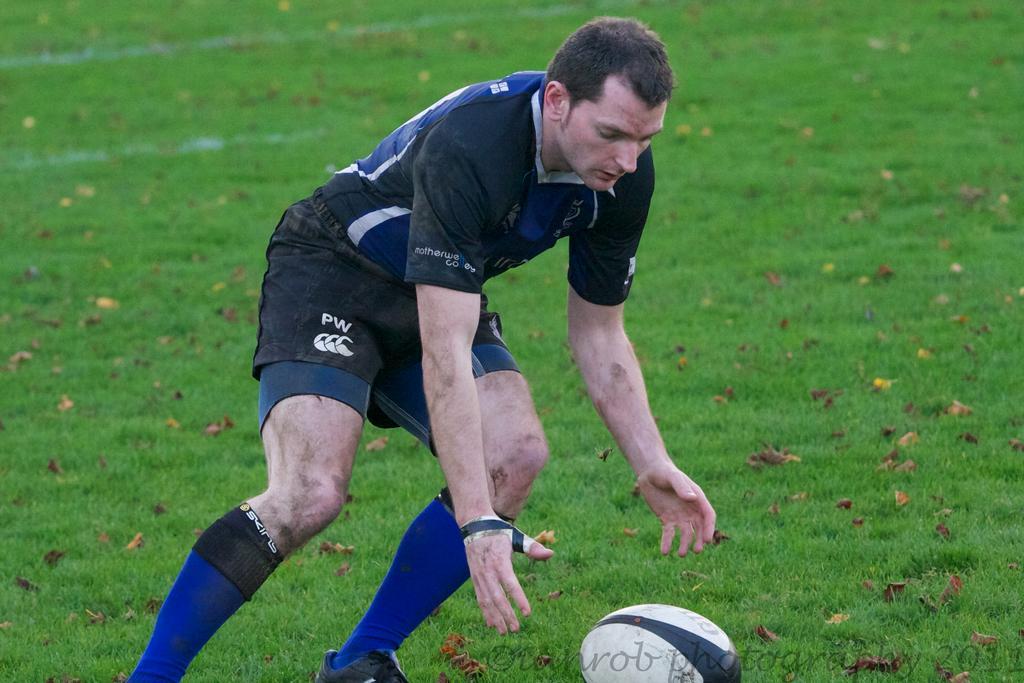In one or two sentences, can you explain what this image depicts? In this picture we can see a person standing on the ground,here we can see a ball. 